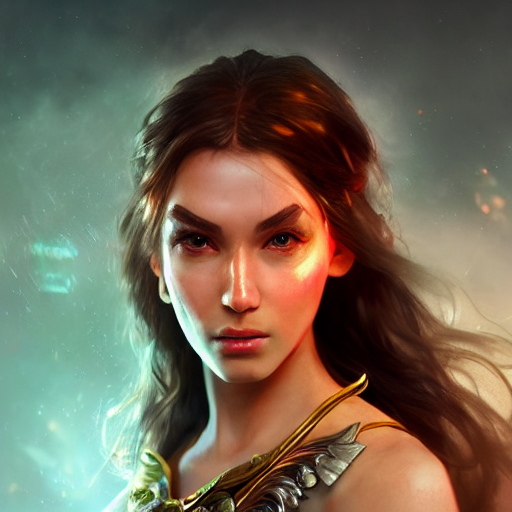Does the image have good lighting? The image features excellent lighting with a striking play of light and shadow that highlights the subject's facial features and creates an intense, dramatic atmosphere. 